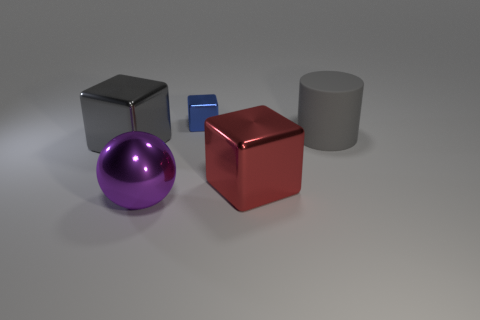Subtract all red blocks. How many blocks are left? 2 Add 3 big gray matte cylinders. How many objects exist? 8 Subtract all gray balls. How many red cubes are left? 1 Subtract all gray blocks. How many blocks are left? 2 Subtract 0 gray spheres. How many objects are left? 5 Subtract all cylinders. How many objects are left? 4 Subtract 2 blocks. How many blocks are left? 1 Subtract all yellow cylinders. Subtract all yellow cubes. How many cylinders are left? 1 Subtract all cyan matte cubes. Subtract all red blocks. How many objects are left? 4 Add 3 big cylinders. How many big cylinders are left? 4 